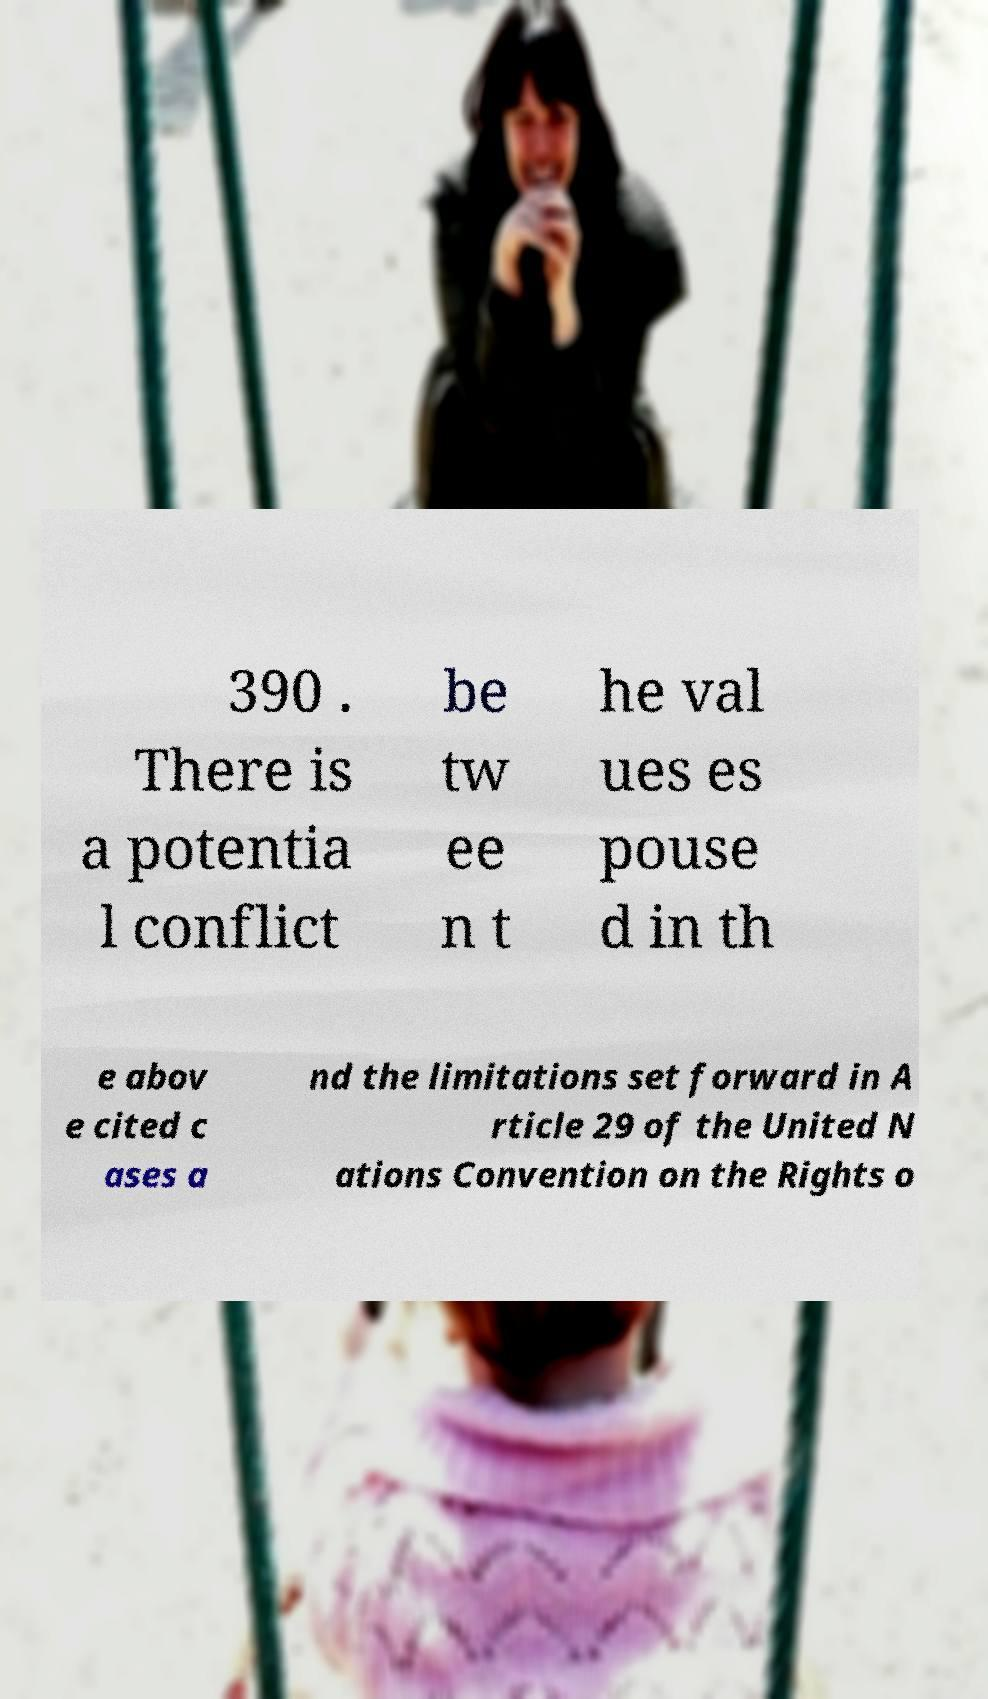There's text embedded in this image that I need extracted. Can you transcribe it verbatim? 390 . There is a potentia l conflict be tw ee n t he val ues es pouse d in th e abov e cited c ases a nd the limitations set forward in A rticle 29 of the United N ations Convention on the Rights o 